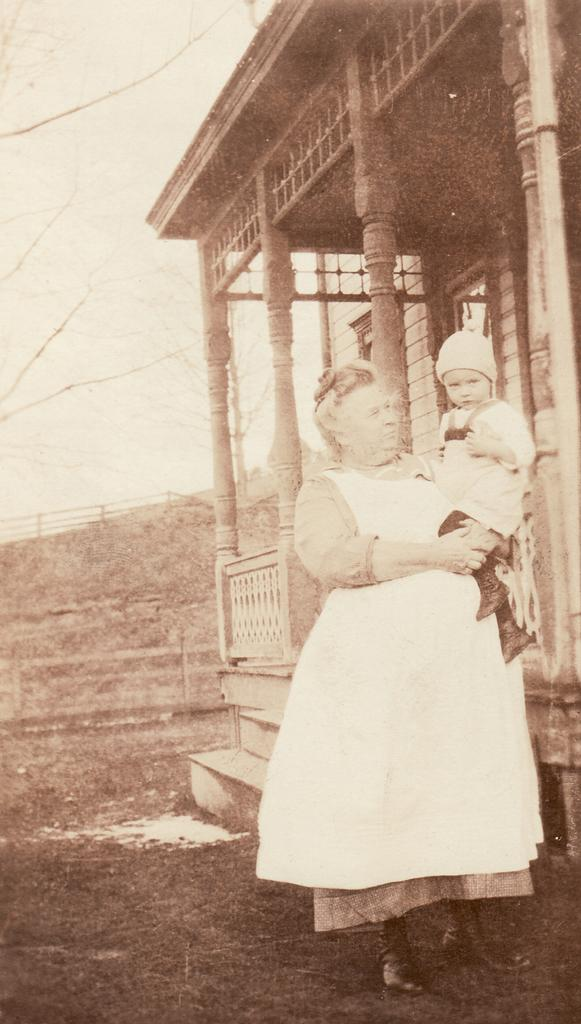Who is the main subject in the image? There is a woman in the image. What is the woman doing in the image? The woman is standing on the ground and carrying a child. What can be seen in the background of the image? There is a building, trees, and the sky visible in the background of the image. What type of guitar is the pig playing in the image? There is no guitar or pig present in the image. What kind of joke is the woman telling the child in the image? There is no joke being told in the image; the woman is simply carrying the child. 